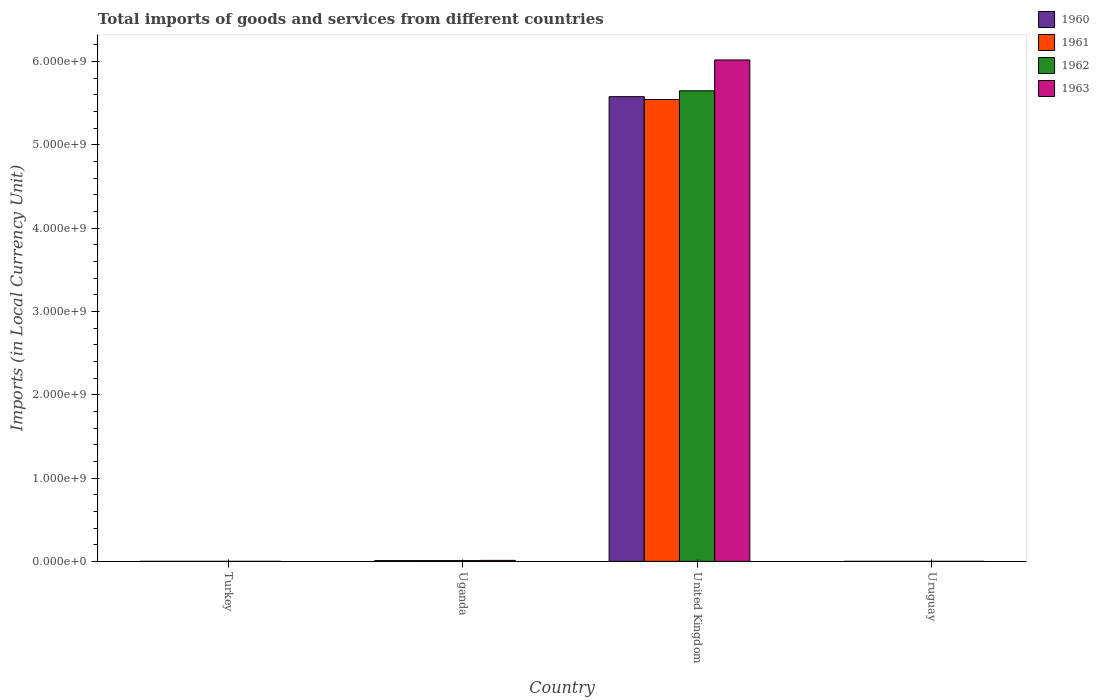How many different coloured bars are there?
Your answer should be very brief. 4. In how many cases, is the number of bars for a given country not equal to the number of legend labels?
Make the answer very short. 0. What is the Amount of goods and services imports in 1961 in United Kingdom?
Ensure brevity in your answer.  5.54e+09. Across all countries, what is the maximum Amount of goods and services imports in 1960?
Ensure brevity in your answer.  5.58e+09. Across all countries, what is the minimum Amount of goods and services imports in 1962?
Make the answer very short. 2800. In which country was the Amount of goods and services imports in 1960 minimum?
Keep it short and to the point. Turkey. What is the total Amount of goods and services imports in 1962 in the graph?
Provide a short and direct response. 5.66e+09. What is the difference between the Amount of goods and services imports in 1960 in Turkey and that in Uganda?
Your answer should be compact. -8.80e+06. What is the difference between the Amount of goods and services imports in 1961 in Uruguay and the Amount of goods and services imports in 1963 in Uganda?
Make the answer very short. -1.18e+07. What is the average Amount of goods and services imports in 1961 per country?
Your response must be concise. 1.39e+09. What is the difference between the Amount of goods and services imports of/in 1962 and Amount of goods and services imports of/in 1960 in United Kingdom?
Ensure brevity in your answer.  7.06e+07. What is the ratio of the Amount of goods and services imports in 1960 in Uganda to that in United Kingdom?
Your answer should be very brief. 0. Is the difference between the Amount of goods and services imports in 1962 in Turkey and United Kingdom greater than the difference between the Amount of goods and services imports in 1960 in Turkey and United Kingdom?
Your response must be concise. No. What is the difference between the highest and the second highest Amount of goods and services imports in 1962?
Give a very brief answer. 5.65e+09. What is the difference between the highest and the lowest Amount of goods and services imports in 1963?
Offer a terse response. 6.02e+09. Is the sum of the Amount of goods and services imports in 1961 in Uganda and United Kingdom greater than the maximum Amount of goods and services imports in 1960 across all countries?
Your response must be concise. No. What does the 2nd bar from the left in Uganda represents?
Provide a succinct answer. 1961. How many bars are there?
Keep it short and to the point. 16. Are all the bars in the graph horizontal?
Offer a terse response. No. How many countries are there in the graph?
Ensure brevity in your answer.  4. What is the difference between two consecutive major ticks on the Y-axis?
Provide a short and direct response. 1.00e+09. Are the values on the major ticks of Y-axis written in scientific E-notation?
Your answer should be very brief. Yes. Does the graph contain any zero values?
Provide a succinct answer. No. How many legend labels are there?
Make the answer very short. 4. How are the legend labels stacked?
Your answer should be compact. Vertical. What is the title of the graph?
Offer a very short reply. Total imports of goods and services from different countries. Does "2003" appear as one of the legend labels in the graph?
Provide a succinct answer. No. What is the label or title of the Y-axis?
Make the answer very short. Imports (in Local Currency Unit). What is the Imports (in Local Currency Unit) in 1960 in Turkey?
Your response must be concise. 2500. What is the Imports (in Local Currency Unit) of 1961 in Turkey?
Offer a very short reply. 4900. What is the Imports (in Local Currency Unit) of 1962 in Turkey?
Offer a very short reply. 6400. What is the Imports (in Local Currency Unit) in 1963 in Turkey?
Your answer should be compact. 6500. What is the Imports (in Local Currency Unit) in 1960 in Uganda?
Your response must be concise. 8.80e+06. What is the Imports (in Local Currency Unit) in 1961 in Uganda?
Offer a very short reply. 9.12e+06. What is the Imports (in Local Currency Unit) of 1962 in Uganda?
Your response must be concise. 9.19e+06. What is the Imports (in Local Currency Unit) of 1963 in Uganda?
Your response must be concise. 1.18e+07. What is the Imports (in Local Currency Unit) in 1960 in United Kingdom?
Keep it short and to the point. 5.58e+09. What is the Imports (in Local Currency Unit) in 1961 in United Kingdom?
Provide a succinct answer. 5.54e+09. What is the Imports (in Local Currency Unit) of 1962 in United Kingdom?
Offer a very short reply. 5.65e+09. What is the Imports (in Local Currency Unit) in 1963 in United Kingdom?
Ensure brevity in your answer.  6.02e+09. What is the Imports (in Local Currency Unit) of 1960 in Uruguay?
Give a very brief answer. 2700. What is the Imports (in Local Currency Unit) of 1961 in Uruguay?
Keep it short and to the point. 2600. What is the Imports (in Local Currency Unit) of 1962 in Uruguay?
Your response must be concise. 2800. What is the Imports (in Local Currency Unit) of 1963 in Uruguay?
Provide a succinct answer. 2800. Across all countries, what is the maximum Imports (in Local Currency Unit) of 1960?
Offer a very short reply. 5.58e+09. Across all countries, what is the maximum Imports (in Local Currency Unit) of 1961?
Your answer should be compact. 5.54e+09. Across all countries, what is the maximum Imports (in Local Currency Unit) in 1962?
Offer a very short reply. 5.65e+09. Across all countries, what is the maximum Imports (in Local Currency Unit) of 1963?
Provide a succinct answer. 6.02e+09. Across all countries, what is the minimum Imports (in Local Currency Unit) in 1960?
Your answer should be very brief. 2500. Across all countries, what is the minimum Imports (in Local Currency Unit) of 1961?
Offer a terse response. 2600. Across all countries, what is the minimum Imports (in Local Currency Unit) of 1962?
Offer a terse response. 2800. Across all countries, what is the minimum Imports (in Local Currency Unit) in 1963?
Your response must be concise. 2800. What is the total Imports (in Local Currency Unit) of 1960 in the graph?
Keep it short and to the point. 5.59e+09. What is the total Imports (in Local Currency Unit) in 1961 in the graph?
Your answer should be compact. 5.55e+09. What is the total Imports (in Local Currency Unit) of 1962 in the graph?
Give a very brief answer. 5.66e+09. What is the total Imports (in Local Currency Unit) of 1963 in the graph?
Offer a very short reply. 6.03e+09. What is the difference between the Imports (in Local Currency Unit) in 1960 in Turkey and that in Uganda?
Your response must be concise. -8.80e+06. What is the difference between the Imports (in Local Currency Unit) in 1961 in Turkey and that in Uganda?
Your answer should be very brief. -9.11e+06. What is the difference between the Imports (in Local Currency Unit) in 1962 in Turkey and that in Uganda?
Offer a very short reply. -9.18e+06. What is the difference between the Imports (in Local Currency Unit) in 1963 in Turkey and that in Uganda?
Give a very brief answer. -1.18e+07. What is the difference between the Imports (in Local Currency Unit) of 1960 in Turkey and that in United Kingdom?
Ensure brevity in your answer.  -5.58e+09. What is the difference between the Imports (in Local Currency Unit) in 1961 in Turkey and that in United Kingdom?
Provide a short and direct response. -5.54e+09. What is the difference between the Imports (in Local Currency Unit) of 1962 in Turkey and that in United Kingdom?
Provide a succinct answer. -5.65e+09. What is the difference between the Imports (in Local Currency Unit) in 1963 in Turkey and that in United Kingdom?
Your answer should be compact. -6.02e+09. What is the difference between the Imports (in Local Currency Unit) in 1960 in Turkey and that in Uruguay?
Make the answer very short. -200. What is the difference between the Imports (in Local Currency Unit) of 1961 in Turkey and that in Uruguay?
Offer a terse response. 2300. What is the difference between the Imports (in Local Currency Unit) in 1962 in Turkey and that in Uruguay?
Your answer should be compact. 3600. What is the difference between the Imports (in Local Currency Unit) in 1963 in Turkey and that in Uruguay?
Provide a short and direct response. 3700. What is the difference between the Imports (in Local Currency Unit) of 1960 in Uganda and that in United Kingdom?
Your answer should be very brief. -5.57e+09. What is the difference between the Imports (in Local Currency Unit) of 1961 in Uganda and that in United Kingdom?
Provide a short and direct response. -5.53e+09. What is the difference between the Imports (in Local Currency Unit) of 1962 in Uganda and that in United Kingdom?
Make the answer very short. -5.64e+09. What is the difference between the Imports (in Local Currency Unit) of 1963 in Uganda and that in United Kingdom?
Provide a short and direct response. -6.01e+09. What is the difference between the Imports (in Local Currency Unit) of 1960 in Uganda and that in Uruguay?
Give a very brief answer. 8.80e+06. What is the difference between the Imports (in Local Currency Unit) in 1961 in Uganda and that in Uruguay?
Ensure brevity in your answer.  9.11e+06. What is the difference between the Imports (in Local Currency Unit) in 1962 in Uganda and that in Uruguay?
Your response must be concise. 9.18e+06. What is the difference between the Imports (in Local Currency Unit) of 1963 in Uganda and that in Uruguay?
Give a very brief answer. 1.18e+07. What is the difference between the Imports (in Local Currency Unit) of 1960 in United Kingdom and that in Uruguay?
Keep it short and to the point. 5.58e+09. What is the difference between the Imports (in Local Currency Unit) in 1961 in United Kingdom and that in Uruguay?
Make the answer very short. 5.54e+09. What is the difference between the Imports (in Local Currency Unit) in 1962 in United Kingdom and that in Uruguay?
Your answer should be very brief. 5.65e+09. What is the difference between the Imports (in Local Currency Unit) of 1963 in United Kingdom and that in Uruguay?
Provide a succinct answer. 6.02e+09. What is the difference between the Imports (in Local Currency Unit) of 1960 in Turkey and the Imports (in Local Currency Unit) of 1961 in Uganda?
Ensure brevity in your answer.  -9.11e+06. What is the difference between the Imports (in Local Currency Unit) in 1960 in Turkey and the Imports (in Local Currency Unit) in 1962 in Uganda?
Your answer should be compact. -9.18e+06. What is the difference between the Imports (in Local Currency Unit) in 1960 in Turkey and the Imports (in Local Currency Unit) in 1963 in Uganda?
Offer a very short reply. -1.18e+07. What is the difference between the Imports (in Local Currency Unit) of 1961 in Turkey and the Imports (in Local Currency Unit) of 1962 in Uganda?
Your answer should be compact. -9.18e+06. What is the difference between the Imports (in Local Currency Unit) in 1961 in Turkey and the Imports (in Local Currency Unit) in 1963 in Uganda?
Your answer should be very brief. -1.18e+07. What is the difference between the Imports (in Local Currency Unit) of 1962 in Turkey and the Imports (in Local Currency Unit) of 1963 in Uganda?
Offer a terse response. -1.18e+07. What is the difference between the Imports (in Local Currency Unit) in 1960 in Turkey and the Imports (in Local Currency Unit) in 1961 in United Kingdom?
Your answer should be very brief. -5.54e+09. What is the difference between the Imports (in Local Currency Unit) of 1960 in Turkey and the Imports (in Local Currency Unit) of 1962 in United Kingdom?
Offer a terse response. -5.65e+09. What is the difference between the Imports (in Local Currency Unit) of 1960 in Turkey and the Imports (in Local Currency Unit) of 1963 in United Kingdom?
Offer a very short reply. -6.02e+09. What is the difference between the Imports (in Local Currency Unit) in 1961 in Turkey and the Imports (in Local Currency Unit) in 1962 in United Kingdom?
Offer a very short reply. -5.65e+09. What is the difference between the Imports (in Local Currency Unit) of 1961 in Turkey and the Imports (in Local Currency Unit) of 1963 in United Kingdom?
Your answer should be very brief. -6.02e+09. What is the difference between the Imports (in Local Currency Unit) of 1962 in Turkey and the Imports (in Local Currency Unit) of 1963 in United Kingdom?
Offer a very short reply. -6.02e+09. What is the difference between the Imports (in Local Currency Unit) of 1960 in Turkey and the Imports (in Local Currency Unit) of 1961 in Uruguay?
Keep it short and to the point. -100. What is the difference between the Imports (in Local Currency Unit) of 1960 in Turkey and the Imports (in Local Currency Unit) of 1962 in Uruguay?
Provide a succinct answer. -300. What is the difference between the Imports (in Local Currency Unit) of 1960 in Turkey and the Imports (in Local Currency Unit) of 1963 in Uruguay?
Your response must be concise. -300. What is the difference between the Imports (in Local Currency Unit) in 1961 in Turkey and the Imports (in Local Currency Unit) in 1962 in Uruguay?
Your answer should be very brief. 2100. What is the difference between the Imports (in Local Currency Unit) of 1961 in Turkey and the Imports (in Local Currency Unit) of 1963 in Uruguay?
Ensure brevity in your answer.  2100. What is the difference between the Imports (in Local Currency Unit) of 1962 in Turkey and the Imports (in Local Currency Unit) of 1963 in Uruguay?
Make the answer very short. 3600. What is the difference between the Imports (in Local Currency Unit) of 1960 in Uganda and the Imports (in Local Currency Unit) of 1961 in United Kingdom?
Keep it short and to the point. -5.54e+09. What is the difference between the Imports (in Local Currency Unit) of 1960 in Uganda and the Imports (in Local Currency Unit) of 1962 in United Kingdom?
Provide a short and direct response. -5.64e+09. What is the difference between the Imports (in Local Currency Unit) in 1960 in Uganda and the Imports (in Local Currency Unit) in 1963 in United Kingdom?
Provide a short and direct response. -6.01e+09. What is the difference between the Imports (in Local Currency Unit) in 1961 in Uganda and the Imports (in Local Currency Unit) in 1962 in United Kingdom?
Provide a succinct answer. -5.64e+09. What is the difference between the Imports (in Local Currency Unit) of 1961 in Uganda and the Imports (in Local Currency Unit) of 1963 in United Kingdom?
Provide a short and direct response. -6.01e+09. What is the difference between the Imports (in Local Currency Unit) of 1962 in Uganda and the Imports (in Local Currency Unit) of 1963 in United Kingdom?
Ensure brevity in your answer.  -6.01e+09. What is the difference between the Imports (in Local Currency Unit) in 1960 in Uganda and the Imports (in Local Currency Unit) in 1961 in Uruguay?
Keep it short and to the point. 8.80e+06. What is the difference between the Imports (in Local Currency Unit) in 1960 in Uganda and the Imports (in Local Currency Unit) in 1962 in Uruguay?
Give a very brief answer. 8.80e+06. What is the difference between the Imports (in Local Currency Unit) in 1960 in Uganda and the Imports (in Local Currency Unit) in 1963 in Uruguay?
Your answer should be very brief. 8.80e+06. What is the difference between the Imports (in Local Currency Unit) of 1961 in Uganda and the Imports (in Local Currency Unit) of 1962 in Uruguay?
Ensure brevity in your answer.  9.11e+06. What is the difference between the Imports (in Local Currency Unit) in 1961 in Uganda and the Imports (in Local Currency Unit) in 1963 in Uruguay?
Offer a very short reply. 9.11e+06. What is the difference between the Imports (in Local Currency Unit) in 1962 in Uganda and the Imports (in Local Currency Unit) in 1963 in Uruguay?
Your answer should be compact. 9.18e+06. What is the difference between the Imports (in Local Currency Unit) of 1960 in United Kingdom and the Imports (in Local Currency Unit) of 1961 in Uruguay?
Offer a terse response. 5.58e+09. What is the difference between the Imports (in Local Currency Unit) in 1960 in United Kingdom and the Imports (in Local Currency Unit) in 1962 in Uruguay?
Your answer should be compact. 5.58e+09. What is the difference between the Imports (in Local Currency Unit) of 1960 in United Kingdom and the Imports (in Local Currency Unit) of 1963 in Uruguay?
Give a very brief answer. 5.58e+09. What is the difference between the Imports (in Local Currency Unit) in 1961 in United Kingdom and the Imports (in Local Currency Unit) in 1962 in Uruguay?
Offer a very short reply. 5.54e+09. What is the difference between the Imports (in Local Currency Unit) of 1961 in United Kingdom and the Imports (in Local Currency Unit) of 1963 in Uruguay?
Offer a terse response. 5.54e+09. What is the difference between the Imports (in Local Currency Unit) in 1962 in United Kingdom and the Imports (in Local Currency Unit) in 1963 in Uruguay?
Give a very brief answer. 5.65e+09. What is the average Imports (in Local Currency Unit) of 1960 per country?
Keep it short and to the point. 1.40e+09. What is the average Imports (in Local Currency Unit) in 1961 per country?
Keep it short and to the point. 1.39e+09. What is the average Imports (in Local Currency Unit) in 1962 per country?
Provide a short and direct response. 1.41e+09. What is the average Imports (in Local Currency Unit) in 1963 per country?
Give a very brief answer. 1.51e+09. What is the difference between the Imports (in Local Currency Unit) in 1960 and Imports (in Local Currency Unit) in 1961 in Turkey?
Offer a very short reply. -2400. What is the difference between the Imports (in Local Currency Unit) in 1960 and Imports (in Local Currency Unit) in 1962 in Turkey?
Provide a succinct answer. -3900. What is the difference between the Imports (in Local Currency Unit) in 1960 and Imports (in Local Currency Unit) in 1963 in Turkey?
Make the answer very short. -4000. What is the difference between the Imports (in Local Currency Unit) in 1961 and Imports (in Local Currency Unit) in 1962 in Turkey?
Your response must be concise. -1500. What is the difference between the Imports (in Local Currency Unit) in 1961 and Imports (in Local Currency Unit) in 1963 in Turkey?
Provide a succinct answer. -1600. What is the difference between the Imports (in Local Currency Unit) in 1962 and Imports (in Local Currency Unit) in 1963 in Turkey?
Your response must be concise. -100. What is the difference between the Imports (in Local Currency Unit) in 1960 and Imports (in Local Currency Unit) in 1961 in Uganda?
Your answer should be very brief. -3.13e+05. What is the difference between the Imports (in Local Currency Unit) in 1960 and Imports (in Local Currency Unit) in 1962 in Uganda?
Your answer should be very brief. -3.83e+05. What is the difference between the Imports (in Local Currency Unit) of 1960 and Imports (in Local Currency Unit) of 1963 in Uganda?
Keep it short and to the point. -2.95e+06. What is the difference between the Imports (in Local Currency Unit) in 1961 and Imports (in Local Currency Unit) in 1962 in Uganda?
Give a very brief answer. -7.06e+04. What is the difference between the Imports (in Local Currency Unit) in 1961 and Imports (in Local Currency Unit) in 1963 in Uganda?
Make the answer very short. -2.64e+06. What is the difference between the Imports (in Local Currency Unit) of 1962 and Imports (in Local Currency Unit) of 1963 in Uganda?
Ensure brevity in your answer.  -2.57e+06. What is the difference between the Imports (in Local Currency Unit) of 1960 and Imports (in Local Currency Unit) of 1961 in United Kingdom?
Provide a short and direct response. 3.38e+07. What is the difference between the Imports (in Local Currency Unit) in 1960 and Imports (in Local Currency Unit) in 1962 in United Kingdom?
Your answer should be compact. -7.06e+07. What is the difference between the Imports (in Local Currency Unit) of 1960 and Imports (in Local Currency Unit) of 1963 in United Kingdom?
Offer a very short reply. -4.41e+08. What is the difference between the Imports (in Local Currency Unit) in 1961 and Imports (in Local Currency Unit) in 1962 in United Kingdom?
Your response must be concise. -1.04e+08. What is the difference between the Imports (in Local Currency Unit) in 1961 and Imports (in Local Currency Unit) in 1963 in United Kingdom?
Give a very brief answer. -4.75e+08. What is the difference between the Imports (in Local Currency Unit) of 1962 and Imports (in Local Currency Unit) of 1963 in United Kingdom?
Your answer should be very brief. -3.70e+08. What is the difference between the Imports (in Local Currency Unit) of 1960 and Imports (in Local Currency Unit) of 1962 in Uruguay?
Provide a short and direct response. -100. What is the difference between the Imports (in Local Currency Unit) of 1960 and Imports (in Local Currency Unit) of 1963 in Uruguay?
Your answer should be very brief. -100. What is the difference between the Imports (in Local Currency Unit) in 1961 and Imports (in Local Currency Unit) in 1962 in Uruguay?
Offer a terse response. -200. What is the difference between the Imports (in Local Currency Unit) of 1961 and Imports (in Local Currency Unit) of 1963 in Uruguay?
Keep it short and to the point. -200. What is the difference between the Imports (in Local Currency Unit) in 1962 and Imports (in Local Currency Unit) in 1963 in Uruguay?
Give a very brief answer. 0. What is the ratio of the Imports (in Local Currency Unit) in 1960 in Turkey to that in Uganda?
Your response must be concise. 0. What is the ratio of the Imports (in Local Currency Unit) of 1961 in Turkey to that in Uganda?
Your response must be concise. 0. What is the ratio of the Imports (in Local Currency Unit) of 1962 in Turkey to that in Uganda?
Your answer should be compact. 0. What is the ratio of the Imports (in Local Currency Unit) in 1963 in Turkey to that in Uganda?
Give a very brief answer. 0. What is the ratio of the Imports (in Local Currency Unit) in 1960 in Turkey to that in United Kingdom?
Ensure brevity in your answer.  0. What is the ratio of the Imports (in Local Currency Unit) of 1961 in Turkey to that in United Kingdom?
Ensure brevity in your answer.  0. What is the ratio of the Imports (in Local Currency Unit) in 1962 in Turkey to that in United Kingdom?
Your answer should be very brief. 0. What is the ratio of the Imports (in Local Currency Unit) in 1960 in Turkey to that in Uruguay?
Your answer should be compact. 0.93. What is the ratio of the Imports (in Local Currency Unit) of 1961 in Turkey to that in Uruguay?
Make the answer very short. 1.88. What is the ratio of the Imports (in Local Currency Unit) of 1962 in Turkey to that in Uruguay?
Ensure brevity in your answer.  2.29. What is the ratio of the Imports (in Local Currency Unit) in 1963 in Turkey to that in Uruguay?
Make the answer very short. 2.32. What is the ratio of the Imports (in Local Currency Unit) in 1960 in Uganda to that in United Kingdom?
Make the answer very short. 0. What is the ratio of the Imports (in Local Currency Unit) of 1961 in Uganda to that in United Kingdom?
Provide a succinct answer. 0. What is the ratio of the Imports (in Local Currency Unit) in 1962 in Uganda to that in United Kingdom?
Keep it short and to the point. 0. What is the ratio of the Imports (in Local Currency Unit) of 1963 in Uganda to that in United Kingdom?
Your answer should be very brief. 0. What is the ratio of the Imports (in Local Currency Unit) in 1960 in Uganda to that in Uruguay?
Your answer should be compact. 3260.74. What is the ratio of the Imports (in Local Currency Unit) in 1961 in Uganda to that in Uruguay?
Offer a very short reply. 3506.42. What is the ratio of the Imports (in Local Currency Unit) of 1962 in Uganda to that in Uruguay?
Make the answer very short. 3281.18. What is the ratio of the Imports (in Local Currency Unit) of 1963 in Uganda to that in Uruguay?
Ensure brevity in your answer.  4199.61. What is the ratio of the Imports (in Local Currency Unit) of 1960 in United Kingdom to that in Uruguay?
Your response must be concise. 2.07e+06. What is the ratio of the Imports (in Local Currency Unit) of 1961 in United Kingdom to that in Uruguay?
Ensure brevity in your answer.  2.13e+06. What is the ratio of the Imports (in Local Currency Unit) of 1962 in United Kingdom to that in Uruguay?
Your answer should be very brief. 2.02e+06. What is the ratio of the Imports (in Local Currency Unit) in 1963 in United Kingdom to that in Uruguay?
Make the answer very short. 2.15e+06. What is the difference between the highest and the second highest Imports (in Local Currency Unit) in 1960?
Keep it short and to the point. 5.57e+09. What is the difference between the highest and the second highest Imports (in Local Currency Unit) of 1961?
Provide a succinct answer. 5.53e+09. What is the difference between the highest and the second highest Imports (in Local Currency Unit) in 1962?
Give a very brief answer. 5.64e+09. What is the difference between the highest and the second highest Imports (in Local Currency Unit) of 1963?
Ensure brevity in your answer.  6.01e+09. What is the difference between the highest and the lowest Imports (in Local Currency Unit) in 1960?
Provide a short and direct response. 5.58e+09. What is the difference between the highest and the lowest Imports (in Local Currency Unit) of 1961?
Provide a succinct answer. 5.54e+09. What is the difference between the highest and the lowest Imports (in Local Currency Unit) in 1962?
Your response must be concise. 5.65e+09. What is the difference between the highest and the lowest Imports (in Local Currency Unit) in 1963?
Offer a terse response. 6.02e+09. 